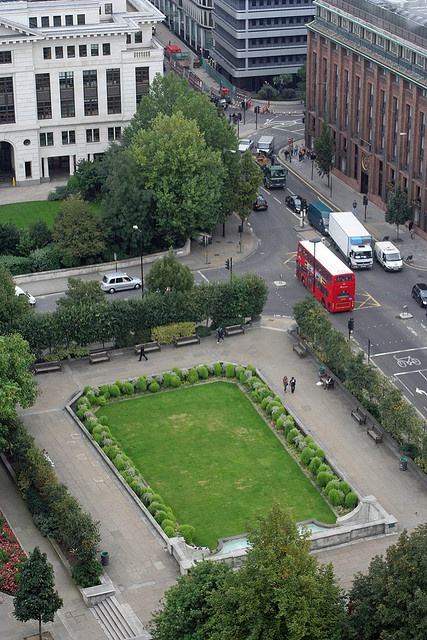Describe the objects in this image and their specific colors. I can see bus in gray, brown, white, and maroon tones, truck in gray, lightgray, darkgray, and black tones, truck in gray, black, and purple tones, car in gray, white, darkgray, and black tones, and car in gray, darkgray, lavender, and black tones in this image. 